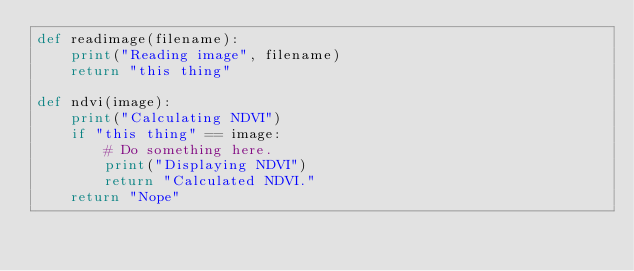<code> <loc_0><loc_0><loc_500><loc_500><_Python_>def readimage(filename):
    print("Reading image", filename)
    return "this thing"

def ndvi(image):
    print("Calculating NDVI")
    if "this thing" == image:
        # Do something here.
        print("Displaying NDVI")
        return "Calculated NDVI."
    return "Nope"</code> 